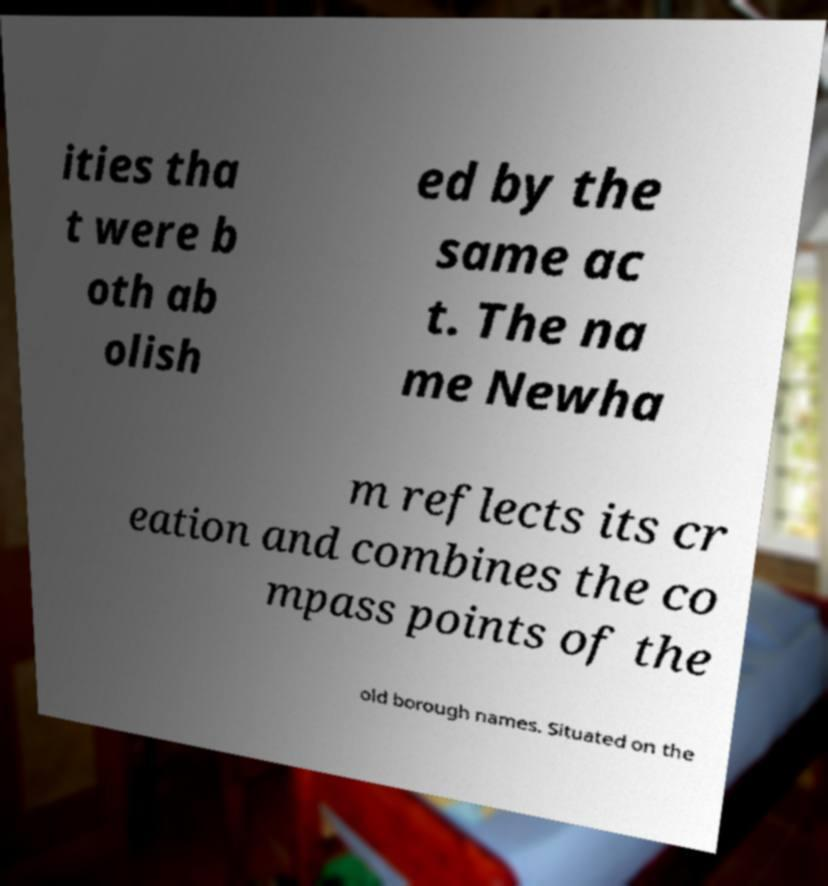What messages or text are displayed in this image? I need them in a readable, typed format. ities tha t were b oth ab olish ed by the same ac t. The na me Newha m reflects its cr eation and combines the co mpass points of the old borough names. Situated on the 